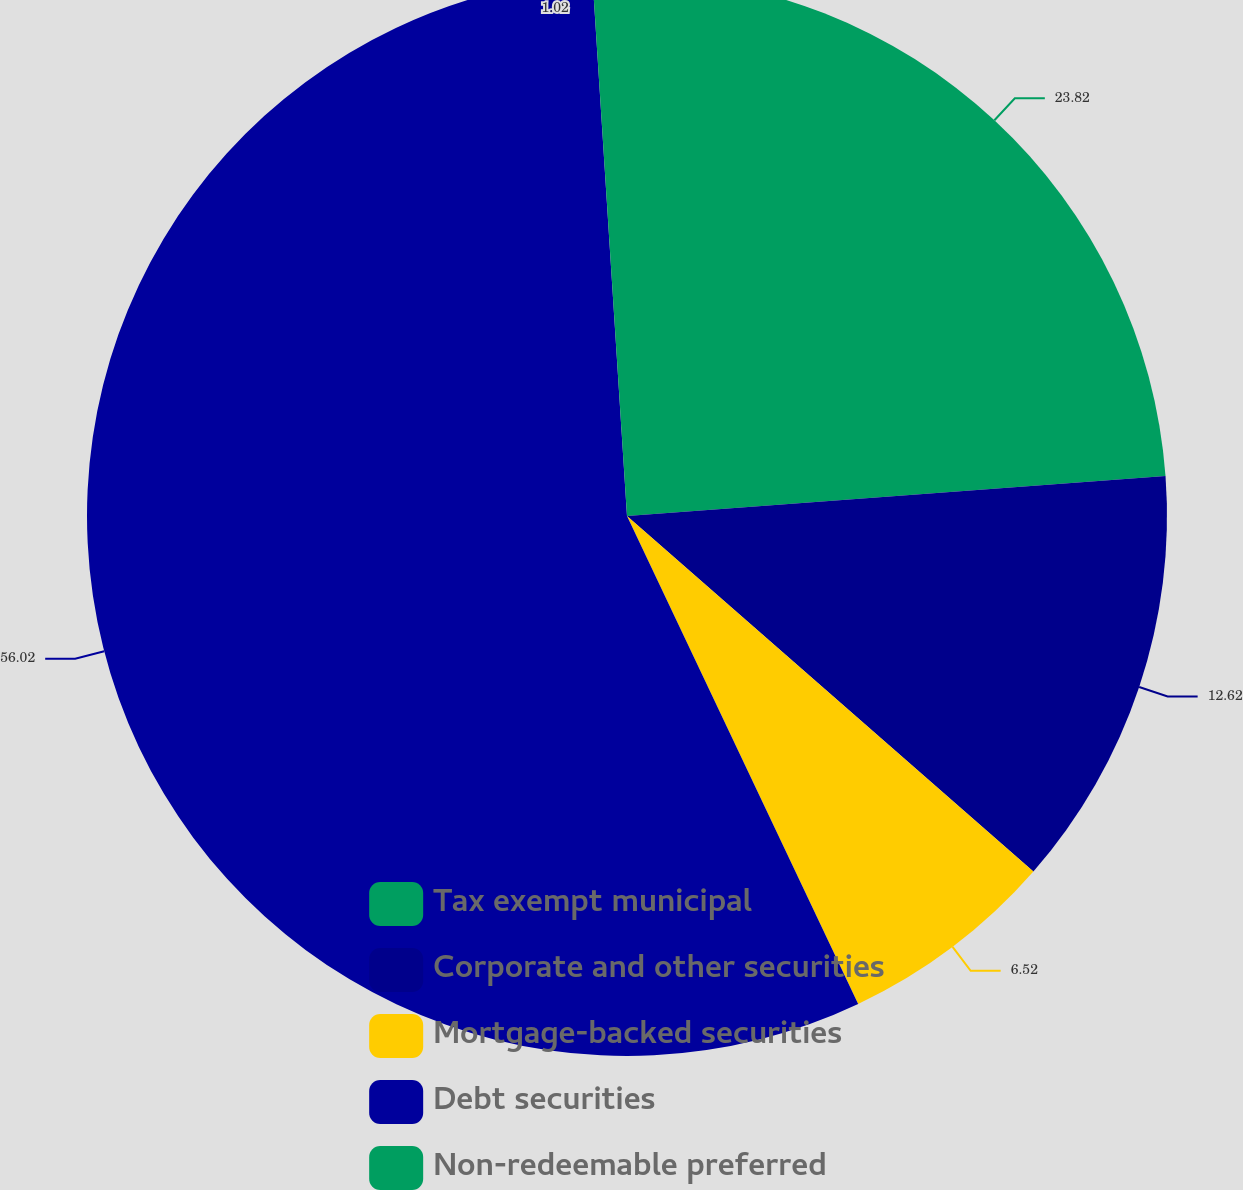Convert chart. <chart><loc_0><loc_0><loc_500><loc_500><pie_chart><fcel>Tax exempt municipal<fcel>Corporate and other securities<fcel>Mortgage-backed securities<fcel>Debt securities<fcel>Non-redeemable preferred<nl><fcel>23.82%<fcel>12.62%<fcel>6.52%<fcel>56.02%<fcel>1.02%<nl></chart> 